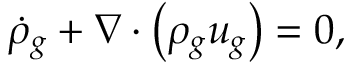<formula> <loc_0><loc_0><loc_500><loc_500>\dot { \rho } _ { g } + \nabla \cdot \left ( \rho _ { g } u _ { g } \right ) = 0 ,</formula> 